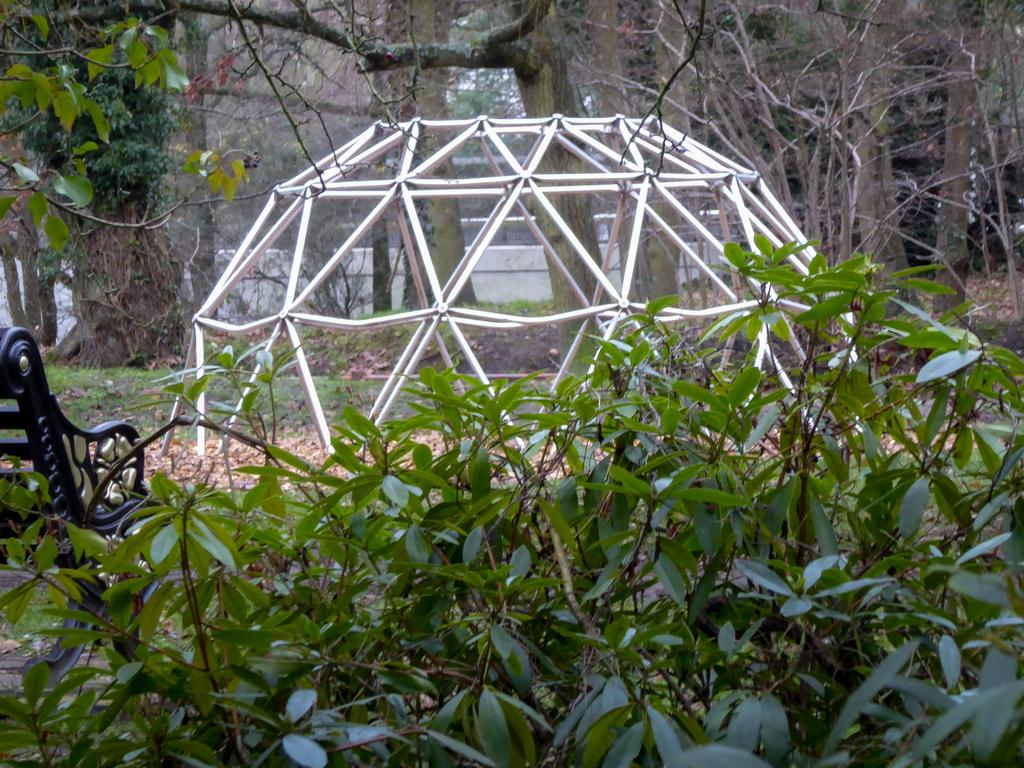What celestial bodies can be seen in the image? There are planets in the image. What type of seating is present in the image? There is a bench in the image. What type of man-made structures can be seen in the image? There is architecture in the image. What type of natural elements can be seen in the image? Dried leaves, grass, and trees are present in the image. What type of barrier is present in the image? There is a wall in the image. How many screws can be seen holding the bench together in the image? There are no screws visible in the image; the bench appears to be made of a solid material. What type of lift can be seen transporting people in the image? There is no lift present in the image; it features a bench, planets, and natural elements. 